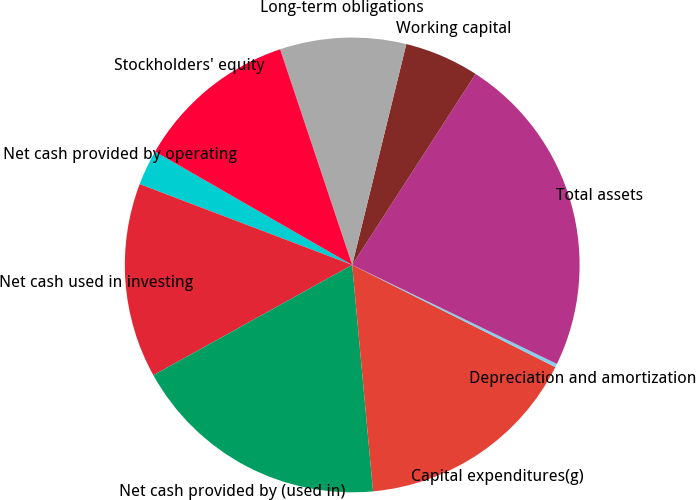Convert chart. <chart><loc_0><loc_0><loc_500><loc_500><pie_chart><fcel>Net cash provided by operating<fcel>Net cash used in investing<fcel>Net cash provided by (used in)<fcel>Capital expenditures(g)<fcel>Depreciation and amortization<fcel>Total assets<fcel>Working capital<fcel>Long-term obligations<fcel>Stockholders' equity<nl><fcel>2.52%<fcel>13.84%<fcel>18.4%<fcel>16.12%<fcel>0.25%<fcel>23.04%<fcel>5.3%<fcel>8.96%<fcel>11.56%<nl></chart> 